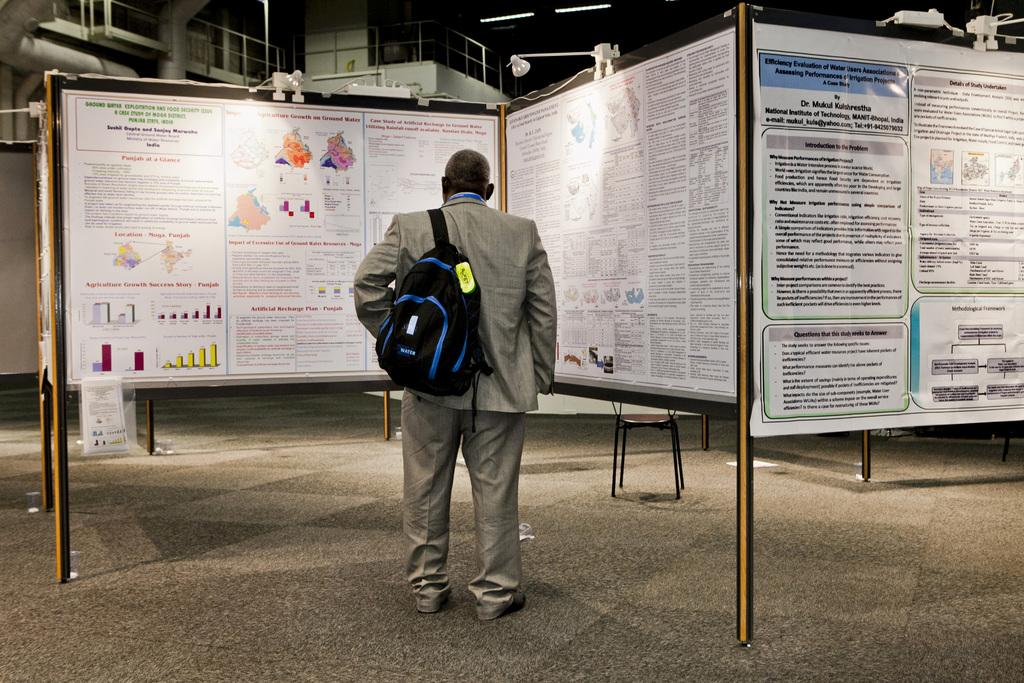Who is present in the image? There is a man in the image. What is the man wearing? The man is wearing a bag. What is the man standing in front of? The man is standing in front of boards. What can be seen on the boards? There are papers on the boards. What type of crow can be seen sitting on the man's shoulder in the image? There is no crow present in the image; the man is standing in front of boards with papers on them. 